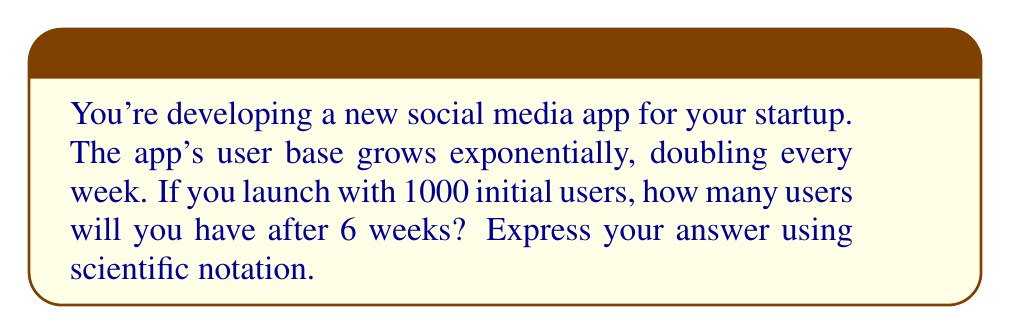Help me with this question. Let's approach this step-by-step:

1) We start with an initial population of 1000 users.

2) The population doubles every week, which means it's multiplied by 2 each week.

3) We can model this with the exponential function:

   $$ P(t) = P_0 \cdot 2^t $$

   Where $P(t)$ is the population at time $t$, $P_0$ is the initial population, and $t$ is the number of weeks.

4) We're given:
   $P_0 = 1000$
   $t = 6$ weeks

5) Let's plug these values into our function:

   $$ P(6) = 1000 \cdot 2^6 $$

6) Now, let's calculate:
   $$ 2^6 = 64 $$

   $$ 1000 \cdot 64 = 64,000 $$

7) To express this in scientific notation, we move the decimal point 4 places to the left:

   $$ 64,000 = 6.4 \times 10^4 $$

Thus, after 6 weeks, you'll have $6.4 \times 10^4$ users.
Answer: $6.4 \times 10^4$ 